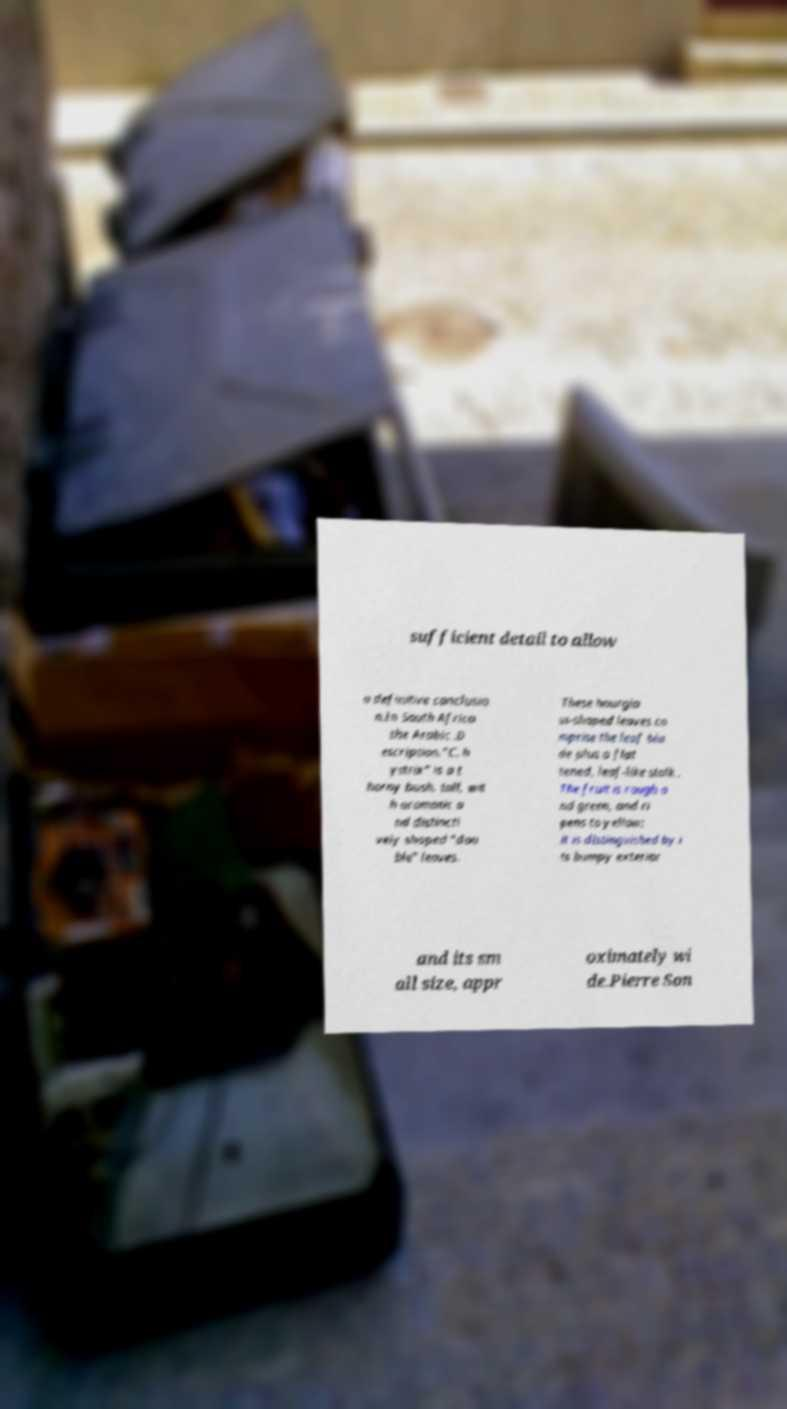I need the written content from this picture converted into text. Can you do that? sufficient detail to allow a definitive conclusio n.In South Africa the Arabic .D escription."C. h ystrix" is a t horny bush, tall, wit h aromatic a nd distincti vely shaped "dou ble" leaves. These hourgla ss-shaped leaves co mprise the leaf bla de plus a flat tened, leaf-like stalk . The fruit is rough a nd green, and ri pens to yellow; it is distinguished by i ts bumpy exterior and its sm all size, appr oximately wi de.Pierre Son 